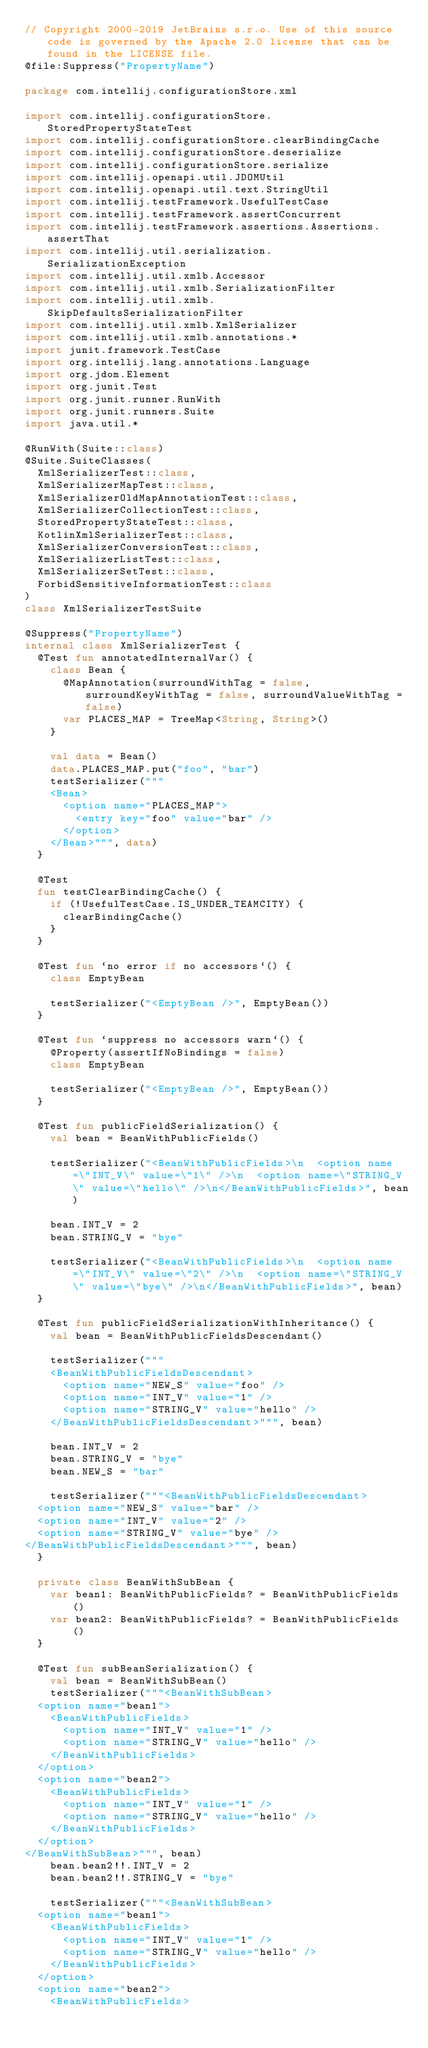<code> <loc_0><loc_0><loc_500><loc_500><_Kotlin_>// Copyright 2000-2019 JetBrains s.r.o. Use of this source code is governed by the Apache 2.0 license that can be found in the LICENSE file.
@file:Suppress("PropertyName")

package com.intellij.configurationStore.xml

import com.intellij.configurationStore.StoredPropertyStateTest
import com.intellij.configurationStore.clearBindingCache
import com.intellij.configurationStore.deserialize
import com.intellij.configurationStore.serialize
import com.intellij.openapi.util.JDOMUtil
import com.intellij.openapi.util.text.StringUtil
import com.intellij.testFramework.UsefulTestCase
import com.intellij.testFramework.assertConcurrent
import com.intellij.testFramework.assertions.Assertions.assertThat
import com.intellij.util.serialization.SerializationException
import com.intellij.util.xmlb.Accessor
import com.intellij.util.xmlb.SerializationFilter
import com.intellij.util.xmlb.SkipDefaultsSerializationFilter
import com.intellij.util.xmlb.XmlSerializer
import com.intellij.util.xmlb.annotations.*
import junit.framework.TestCase
import org.intellij.lang.annotations.Language
import org.jdom.Element
import org.junit.Test
import org.junit.runner.RunWith
import org.junit.runners.Suite
import java.util.*

@RunWith(Suite::class)
@Suite.SuiteClasses(
  XmlSerializerTest::class,
  XmlSerializerMapTest::class,
  XmlSerializerOldMapAnnotationTest::class,
  XmlSerializerCollectionTest::class,
  StoredPropertyStateTest::class,
  KotlinXmlSerializerTest::class,
  XmlSerializerConversionTest::class,
  XmlSerializerListTest::class,
  XmlSerializerSetTest::class,
  ForbidSensitiveInformationTest::class
)
class XmlSerializerTestSuite

@Suppress("PropertyName")
internal class XmlSerializerTest {
  @Test fun annotatedInternalVar() {
    class Bean {
      @MapAnnotation(surroundWithTag = false, surroundKeyWithTag = false, surroundValueWithTag = false)
      var PLACES_MAP = TreeMap<String, String>()
    }

    val data = Bean()
    data.PLACES_MAP.put("foo", "bar")
    testSerializer("""
    <Bean>
      <option name="PLACES_MAP">
        <entry key="foo" value="bar" />
      </option>
    </Bean>""", data)
  }

  @Test
  fun testClearBindingCache() {
    if (!UsefulTestCase.IS_UNDER_TEAMCITY) {
      clearBindingCache()
    }
  }

  @Test fun `no error if no accessors`() {
    class EmptyBean

    testSerializer("<EmptyBean />", EmptyBean())
  }

  @Test fun `suppress no accessors warn`() {
    @Property(assertIfNoBindings = false)
    class EmptyBean

    testSerializer("<EmptyBean />", EmptyBean())
  }

  @Test fun publicFieldSerialization() {
    val bean = BeanWithPublicFields()

    testSerializer("<BeanWithPublicFields>\n  <option name=\"INT_V\" value=\"1\" />\n  <option name=\"STRING_V\" value=\"hello\" />\n</BeanWithPublicFields>", bean)

    bean.INT_V = 2
    bean.STRING_V = "bye"

    testSerializer("<BeanWithPublicFields>\n  <option name=\"INT_V\" value=\"2\" />\n  <option name=\"STRING_V\" value=\"bye\" />\n</BeanWithPublicFields>", bean)
  }

  @Test fun publicFieldSerializationWithInheritance() {
    val bean = BeanWithPublicFieldsDescendant()

    testSerializer("""
    <BeanWithPublicFieldsDescendant>
      <option name="NEW_S" value="foo" />
      <option name="INT_V" value="1" />
      <option name="STRING_V" value="hello" />
    </BeanWithPublicFieldsDescendant>""", bean)

    bean.INT_V = 2
    bean.STRING_V = "bye"
    bean.NEW_S = "bar"

    testSerializer("""<BeanWithPublicFieldsDescendant>
  <option name="NEW_S" value="bar" />
  <option name="INT_V" value="2" />
  <option name="STRING_V" value="bye" />
</BeanWithPublicFieldsDescendant>""", bean)
  }

  private class BeanWithSubBean {
    var bean1: BeanWithPublicFields? = BeanWithPublicFields()
    var bean2: BeanWithPublicFields? = BeanWithPublicFields()
  }

  @Test fun subBeanSerialization() {
    val bean = BeanWithSubBean()
    testSerializer("""<BeanWithSubBean>
  <option name="bean1">
    <BeanWithPublicFields>
      <option name="INT_V" value="1" />
      <option name="STRING_V" value="hello" />
    </BeanWithPublicFields>
  </option>
  <option name="bean2">
    <BeanWithPublicFields>
      <option name="INT_V" value="1" />
      <option name="STRING_V" value="hello" />
    </BeanWithPublicFields>
  </option>
</BeanWithSubBean>""", bean)
    bean.bean2!!.INT_V = 2
    bean.bean2!!.STRING_V = "bye"

    testSerializer("""<BeanWithSubBean>
  <option name="bean1">
    <BeanWithPublicFields>
      <option name="INT_V" value="1" />
      <option name="STRING_V" value="hello" />
    </BeanWithPublicFields>
  </option>
  <option name="bean2">
    <BeanWithPublicFields></code> 